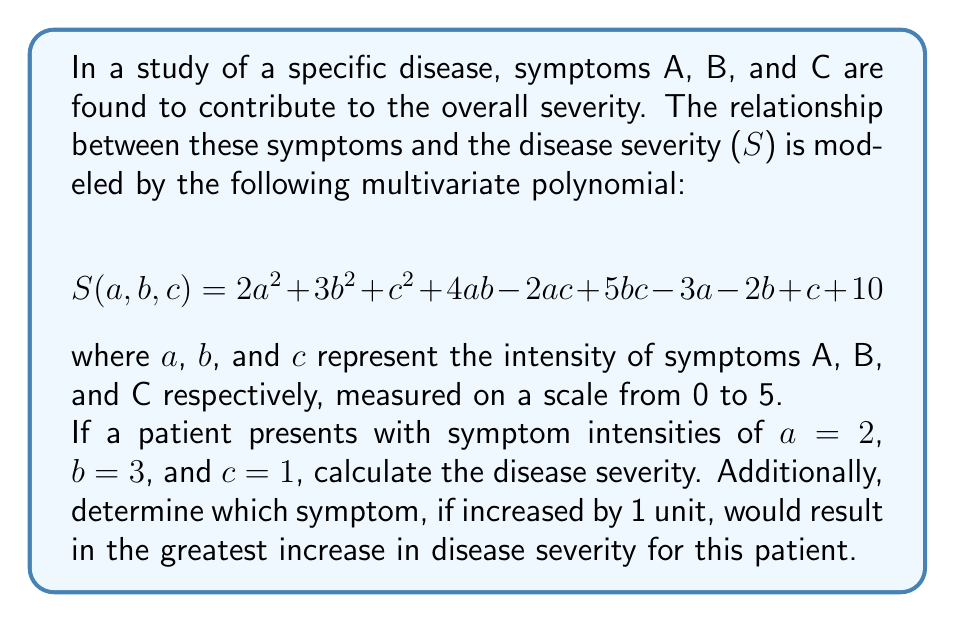Can you answer this question? To solve this problem, we'll follow these steps:

1. Calculate the current disease severity:
   Substitute a = 2, b = 3, and c = 1 into the given polynomial:

   $$S(2,3,1) = 2(2)^2 + 3(3)^2 + (1)^2 + 4(2)(3) - 2(2)(1) + 5(3)(1) - 3(2) - 2(3) + 1 + 10$$

   $$= 2(4) + 3(9) + 1 + 24 - 4 + 15 - 6 - 6 + 1 + 10$$
   
   $$= 8 + 27 + 1 + 24 - 4 + 15 - 6 - 6 + 1 + 10$$
   
   $$= 70$$

2. Calculate the partial derivatives to determine which symptom would cause the greatest increase:

   $$\frac{\partial S}{\partial a} = 4a + 4b - 2c - 3$$
   $$\frac{\partial S}{\partial b} = 6b + 4a + 5c - 2$$
   $$\frac{\partial S}{\partial c} = 2c - 2a + 5b + 1$$

3. Evaluate each partial derivative at the given point (2, 3, 1):

   $$\frac{\partial S}{\partial a}(2,3,1) = 4(2) + 4(3) - 2(1) - 3 = 8 + 12 - 2 - 3 = 15$$
   $$\frac{\partial S}{\partial b}(2,3,1) = 6(3) + 4(2) + 5(1) - 2 = 18 + 8 + 5 - 2 = 29$$
   $$\frac{\partial S}{\partial c}(2,3,1) = 2(1) - 2(2) + 5(3) + 1 = 2 - 4 + 15 + 1 = 14$$

4. Compare the values of the partial derivatives:

   The largest value is 29, corresponding to $\frac{\partial S}{\partial b}$. This means that increasing symptom B by 1 unit would result in the greatest increase in disease severity for this patient.
Answer: 70; Symptom B 